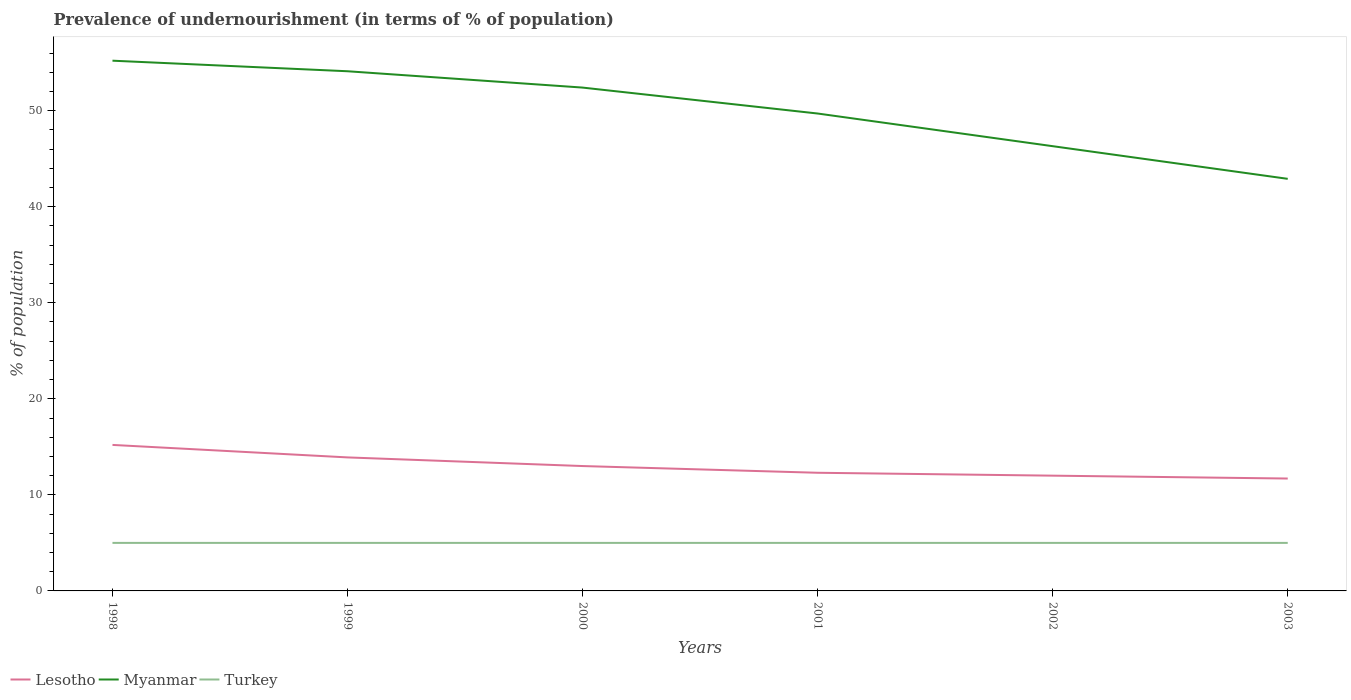How many different coloured lines are there?
Ensure brevity in your answer.  3. Does the line corresponding to Lesotho intersect with the line corresponding to Myanmar?
Provide a short and direct response. No. Across all years, what is the maximum percentage of undernourished population in Turkey?
Give a very brief answer. 5. What is the difference between the highest and the second highest percentage of undernourished population in Turkey?
Give a very brief answer. 0. How many years are there in the graph?
Offer a terse response. 6. Are the values on the major ticks of Y-axis written in scientific E-notation?
Make the answer very short. No. Does the graph contain any zero values?
Provide a succinct answer. No. What is the title of the graph?
Ensure brevity in your answer.  Prevalence of undernourishment (in terms of % of population). Does "European Union" appear as one of the legend labels in the graph?
Your answer should be compact. No. What is the label or title of the Y-axis?
Your response must be concise. % of population. What is the % of population in Myanmar in 1998?
Your response must be concise. 55.2. What is the % of population of Turkey in 1998?
Give a very brief answer. 5. What is the % of population in Lesotho in 1999?
Make the answer very short. 13.9. What is the % of population of Myanmar in 1999?
Give a very brief answer. 54.1. What is the % of population in Lesotho in 2000?
Your answer should be very brief. 13. What is the % of population in Myanmar in 2000?
Provide a succinct answer. 52.4. What is the % of population in Turkey in 2000?
Give a very brief answer. 5. What is the % of population of Myanmar in 2001?
Your response must be concise. 49.7. What is the % of population in Lesotho in 2002?
Your answer should be very brief. 12. What is the % of population of Myanmar in 2002?
Ensure brevity in your answer.  46.3. What is the % of population in Turkey in 2002?
Provide a succinct answer. 5. What is the % of population in Myanmar in 2003?
Offer a very short reply. 42.9. Across all years, what is the maximum % of population in Lesotho?
Ensure brevity in your answer.  15.2. Across all years, what is the maximum % of population of Myanmar?
Your response must be concise. 55.2. Across all years, what is the maximum % of population in Turkey?
Make the answer very short. 5. Across all years, what is the minimum % of population of Myanmar?
Offer a very short reply. 42.9. What is the total % of population of Lesotho in the graph?
Provide a short and direct response. 78.1. What is the total % of population in Myanmar in the graph?
Your response must be concise. 300.6. What is the difference between the % of population in Myanmar in 1998 and that in 1999?
Ensure brevity in your answer.  1.1. What is the difference between the % of population in Turkey in 1998 and that in 1999?
Offer a very short reply. 0. What is the difference between the % of population in Lesotho in 1998 and that in 2000?
Offer a very short reply. 2.2. What is the difference between the % of population of Myanmar in 1998 and that in 2000?
Keep it short and to the point. 2.8. What is the difference between the % of population of Turkey in 1998 and that in 2001?
Give a very brief answer. 0. What is the difference between the % of population in Turkey in 1998 and that in 2002?
Make the answer very short. 0. What is the difference between the % of population in Lesotho in 1998 and that in 2003?
Your answer should be very brief. 3.5. What is the difference between the % of population in Myanmar in 1998 and that in 2003?
Provide a succinct answer. 12.3. What is the difference between the % of population in Turkey in 1998 and that in 2003?
Your answer should be very brief. 0. What is the difference between the % of population of Lesotho in 1999 and that in 2000?
Make the answer very short. 0.9. What is the difference between the % of population of Myanmar in 1999 and that in 2001?
Offer a very short reply. 4.4. What is the difference between the % of population of Turkey in 1999 and that in 2001?
Offer a very short reply. 0. What is the difference between the % of population in Lesotho in 2000 and that in 2001?
Offer a terse response. 0.7. What is the difference between the % of population of Turkey in 2000 and that in 2002?
Offer a terse response. 0. What is the difference between the % of population in Myanmar in 2000 and that in 2003?
Your response must be concise. 9.5. What is the difference between the % of population of Myanmar in 2001 and that in 2002?
Your answer should be very brief. 3.4. What is the difference between the % of population in Turkey in 2001 and that in 2003?
Keep it short and to the point. 0. What is the difference between the % of population of Turkey in 2002 and that in 2003?
Offer a terse response. 0. What is the difference between the % of population in Lesotho in 1998 and the % of population in Myanmar in 1999?
Give a very brief answer. -38.9. What is the difference between the % of population of Myanmar in 1998 and the % of population of Turkey in 1999?
Provide a short and direct response. 50.2. What is the difference between the % of population of Lesotho in 1998 and the % of population of Myanmar in 2000?
Your response must be concise. -37.2. What is the difference between the % of population in Myanmar in 1998 and the % of population in Turkey in 2000?
Offer a terse response. 50.2. What is the difference between the % of population in Lesotho in 1998 and the % of population in Myanmar in 2001?
Your answer should be very brief. -34.5. What is the difference between the % of population in Lesotho in 1998 and the % of population in Turkey in 2001?
Provide a succinct answer. 10.2. What is the difference between the % of population in Myanmar in 1998 and the % of population in Turkey in 2001?
Make the answer very short. 50.2. What is the difference between the % of population in Lesotho in 1998 and the % of population in Myanmar in 2002?
Your answer should be compact. -31.1. What is the difference between the % of population in Myanmar in 1998 and the % of population in Turkey in 2002?
Keep it short and to the point. 50.2. What is the difference between the % of population of Lesotho in 1998 and the % of population of Myanmar in 2003?
Provide a short and direct response. -27.7. What is the difference between the % of population of Myanmar in 1998 and the % of population of Turkey in 2003?
Make the answer very short. 50.2. What is the difference between the % of population in Lesotho in 1999 and the % of population in Myanmar in 2000?
Make the answer very short. -38.5. What is the difference between the % of population of Myanmar in 1999 and the % of population of Turkey in 2000?
Your response must be concise. 49.1. What is the difference between the % of population of Lesotho in 1999 and the % of population of Myanmar in 2001?
Provide a short and direct response. -35.8. What is the difference between the % of population in Myanmar in 1999 and the % of population in Turkey in 2001?
Your answer should be very brief. 49.1. What is the difference between the % of population of Lesotho in 1999 and the % of population of Myanmar in 2002?
Ensure brevity in your answer.  -32.4. What is the difference between the % of population in Myanmar in 1999 and the % of population in Turkey in 2002?
Provide a succinct answer. 49.1. What is the difference between the % of population in Lesotho in 1999 and the % of population in Myanmar in 2003?
Give a very brief answer. -29. What is the difference between the % of population of Lesotho in 1999 and the % of population of Turkey in 2003?
Your answer should be very brief. 8.9. What is the difference between the % of population of Myanmar in 1999 and the % of population of Turkey in 2003?
Offer a very short reply. 49.1. What is the difference between the % of population in Lesotho in 2000 and the % of population in Myanmar in 2001?
Give a very brief answer. -36.7. What is the difference between the % of population of Lesotho in 2000 and the % of population of Turkey in 2001?
Make the answer very short. 8. What is the difference between the % of population in Myanmar in 2000 and the % of population in Turkey in 2001?
Ensure brevity in your answer.  47.4. What is the difference between the % of population in Lesotho in 2000 and the % of population in Myanmar in 2002?
Your response must be concise. -33.3. What is the difference between the % of population of Myanmar in 2000 and the % of population of Turkey in 2002?
Provide a succinct answer. 47.4. What is the difference between the % of population in Lesotho in 2000 and the % of population in Myanmar in 2003?
Ensure brevity in your answer.  -29.9. What is the difference between the % of population in Lesotho in 2000 and the % of population in Turkey in 2003?
Provide a succinct answer. 8. What is the difference between the % of population in Myanmar in 2000 and the % of population in Turkey in 2003?
Your response must be concise. 47.4. What is the difference between the % of population of Lesotho in 2001 and the % of population of Myanmar in 2002?
Your answer should be compact. -34. What is the difference between the % of population in Lesotho in 2001 and the % of population in Turkey in 2002?
Offer a terse response. 7.3. What is the difference between the % of population in Myanmar in 2001 and the % of population in Turkey in 2002?
Your answer should be compact. 44.7. What is the difference between the % of population of Lesotho in 2001 and the % of population of Myanmar in 2003?
Give a very brief answer. -30.6. What is the difference between the % of population of Lesotho in 2001 and the % of population of Turkey in 2003?
Offer a terse response. 7.3. What is the difference between the % of population in Myanmar in 2001 and the % of population in Turkey in 2003?
Make the answer very short. 44.7. What is the difference between the % of population of Lesotho in 2002 and the % of population of Myanmar in 2003?
Your answer should be very brief. -30.9. What is the difference between the % of population in Lesotho in 2002 and the % of population in Turkey in 2003?
Your answer should be compact. 7. What is the difference between the % of population in Myanmar in 2002 and the % of population in Turkey in 2003?
Your answer should be compact. 41.3. What is the average % of population of Lesotho per year?
Your response must be concise. 13.02. What is the average % of population in Myanmar per year?
Give a very brief answer. 50.1. In the year 1998, what is the difference between the % of population in Lesotho and % of population in Myanmar?
Ensure brevity in your answer.  -40. In the year 1998, what is the difference between the % of population in Myanmar and % of population in Turkey?
Your answer should be compact. 50.2. In the year 1999, what is the difference between the % of population in Lesotho and % of population in Myanmar?
Provide a short and direct response. -40.2. In the year 1999, what is the difference between the % of population of Myanmar and % of population of Turkey?
Your answer should be compact. 49.1. In the year 2000, what is the difference between the % of population in Lesotho and % of population in Myanmar?
Your response must be concise. -39.4. In the year 2000, what is the difference between the % of population of Myanmar and % of population of Turkey?
Your response must be concise. 47.4. In the year 2001, what is the difference between the % of population in Lesotho and % of population in Myanmar?
Your response must be concise. -37.4. In the year 2001, what is the difference between the % of population in Lesotho and % of population in Turkey?
Give a very brief answer. 7.3. In the year 2001, what is the difference between the % of population in Myanmar and % of population in Turkey?
Ensure brevity in your answer.  44.7. In the year 2002, what is the difference between the % of population of Lesotho and % of population of Myanmar?
Your response must be concise. -34.3. In the year 2002, what is the difference between the % of population in Lesotho and % of population in Turkey?
Provide a succinct answer. 7. In the year 2002, what is the difference between the % of population of Myanmar and % of population of Turkey?
Provide a short and direct response. 41.3. In the year 2003, what is the difference between the % of population of Lesotho and % of population of Myanmar?
Keep it short and to the point. -31.2. In the year 2003, what is the difference between the % of population in Lesotho and % of population in Turkey?
Offer a very short reply. 6.7. In the year 2003, what is the difference between the % of population in Myanmar and % of population in Turkey?
Ensure brevity in your answer.  37.9. What is the ratio of the % of population of Lesotho in 1998 to that in 1999?
Your answer should be very brief. 1.09. What is the ratio of the % of population in Myanmar in 1998 to that in 1999?
Your answer should be compact. 1.02. What is the ratio of the % of population in Lesotho in 1998 to that in 2000?
Make the answer very short. 1.17. What is the ratio of the % of population of Myanmar in 1998 to that in 2000?
Provide a succinct answer. 1.05. What is the ratio of the % of population in Turkey in 1998 to that in 2000?
Your answer should be compact. 1. What is the ratio of the % of population in Lesotho in 1998 to that in 2001?
Make the answer very short. 1.24. What is the ratio of the % of population of Myanmar in 1998 to that in 2001?
Provide a short and direct response. 1.11. What is the ratio of the % of population of Lesotho in 1998 to that in 2002?
Make the answer very short. 1.27. What is the ratio of the % of population in Myanmar in 1998 to that in 2002?
Offer a terse response. 1.19. What is the ratio of the % of population of Lesotho in 1998 to that in 2003?
Offer a very short reply. 1.3. What is the ratio of the % of population of Myanmar in 1998 to that in 2003?
Offer a very short reply. 1.29. What is the ratio of the % of population in Lesotho in 1999 to that in 2000?
Make the answer very short. 1.07. What is the ratio of the % of population of Myanmar in 1999 to that in 2000?
Offer a terse response. 1.03. What is the ratio of the % of population in Turkey in 1999 to that in 2000?
Provide a short and direct response. 1. What is the ratio of the % of population of Lesotho in 1999 to that in 2001?
Provide a succinct answer. 1.13. What is the ratio of the % of population of Myanmar in 1999 to that in 2001?
Give a very brief answer. 1.09. What is the ratio of the % of population of Lesotho in 1999 to that in 2002?
Your answer should be compact. 1.16. What is the ratio of the % of population of Myanmar in 1999 to that in 2002?
Provide a succinct answer. 1.17. What is the ratio of the % of population of Turkey in 1999 to that in 2002?
Ensure brevity in your answer.  1. What is the ratio of the % of population of Lesotho in 1999 to that in 2003?
Provide a succinct answer. 1.19. What is the ratio of the % of population in Myanmar in 1999 to that in 2003?
Ensure brevity in your answer.  1.26. What is the ratio of the % of population of Lesotho in 2000 to that in 2001?
Your answer should be compact. 1.06. What is the ratio of the % of population of Myanmar in 2000 to that in 2001?
Offer a very short reply. 1.05. What is the ratio of the % of population in Turkey in 2000 to that in 2001?
Provide a succinct answer. 1. What is the ratio of the % of population in Lesotho in 2000 to that in 2002?
Your response must be concise. 1.08. What is the ratio of the % of population in Myanmar in 2000 to that in 2002?
Make the answer very short. 1.13. What is the ratio of the % of population in Lesotho in 2000 to that in 2003?
Give a very brief answer. 1.11. What is the ratio of the % of population in Myanmar in 2000 to that in 2003?
Make the answer very short. 1.22. What is the ratio of the % of population of Turkey in 2000 to that in 2003?
Your answer should be compact. 1. What is the ratio of the % of population in Myanmar in 2001 to that in 2002?
Offer a terse response. 1.07. What is the ratio of the % of population in Lesotho in 2001 to that in 2003?
Your answer should be compact. 1.05. What is the ratio of the % of population in Myanmar in 2001 to that in 2003?
Your response must be concise. 1.16. What is the ratio of the % of population of Turkey in 2001 to that in 2003?
Provide a succinct answer. 1. What is the ratio of the % of population in Lesotho in 2002 to that in 2003?
Provide a succinct answer. 1.03. What is the ratio of the % of population of Myanmar in 2002 to that in 2003?
Your answer should be very brief. 1.08. What is the difference between the highest and the second highest % of population of Lesotho?
Offer a very short reply. 1.3. What is the difference between the highest and the second highest % of population of Myanmar?
Make the answer very short. 1.1. What is the difference between the highest and the lowest % of population in Myanmar?
Your answer should be compact. 12.3. 